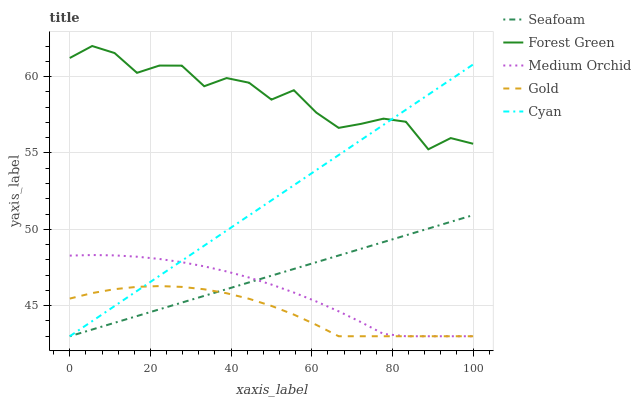Does Gold have the minimum area under the curve?
Answer yes or no. Yes. Does Forest Green have the maximum area under the curve?
Answer yes or no. Yes. Does Medium Orchid have the minimum area under the curve?
Answer yes or no. No. Does Medium Orchid have the maximum area under the curve?
Answer yes or no. No. Is Cyan the smoothest?
Answer yes or no. Yes. Is Forest Green the roughest?
Answer yes or no. Yes. Is Medium Orchid the smoothest?
Answer yes or no. No. Is Medium Orchid the roughest?
Answer yes or no. No. Does Cyan have the lowest value?
Answer yes or no. Yes. Does Forest Green have the lowest value?
Answer yes or no. No. Does Forest Green have the highest value?
Answer yes or no. Yes. Does Medium Orchid have the highest value?
Answer yes or no. No. Is Medium Orchid less than Forest Green?
Answer yes or no. Yes. Is Forest Green greater than Seafoam?
Answer yes or no. Yes. Does Gold intersect Seafoam?
Answer yes or no. Yes. Is Gold less than Seafoam?
Answer yes or no. No. Is Gold greater than Seafoam?
Answer yes or no. No. Does Medium Orchid intersect Forest Green?
Answer yes or no. No. 